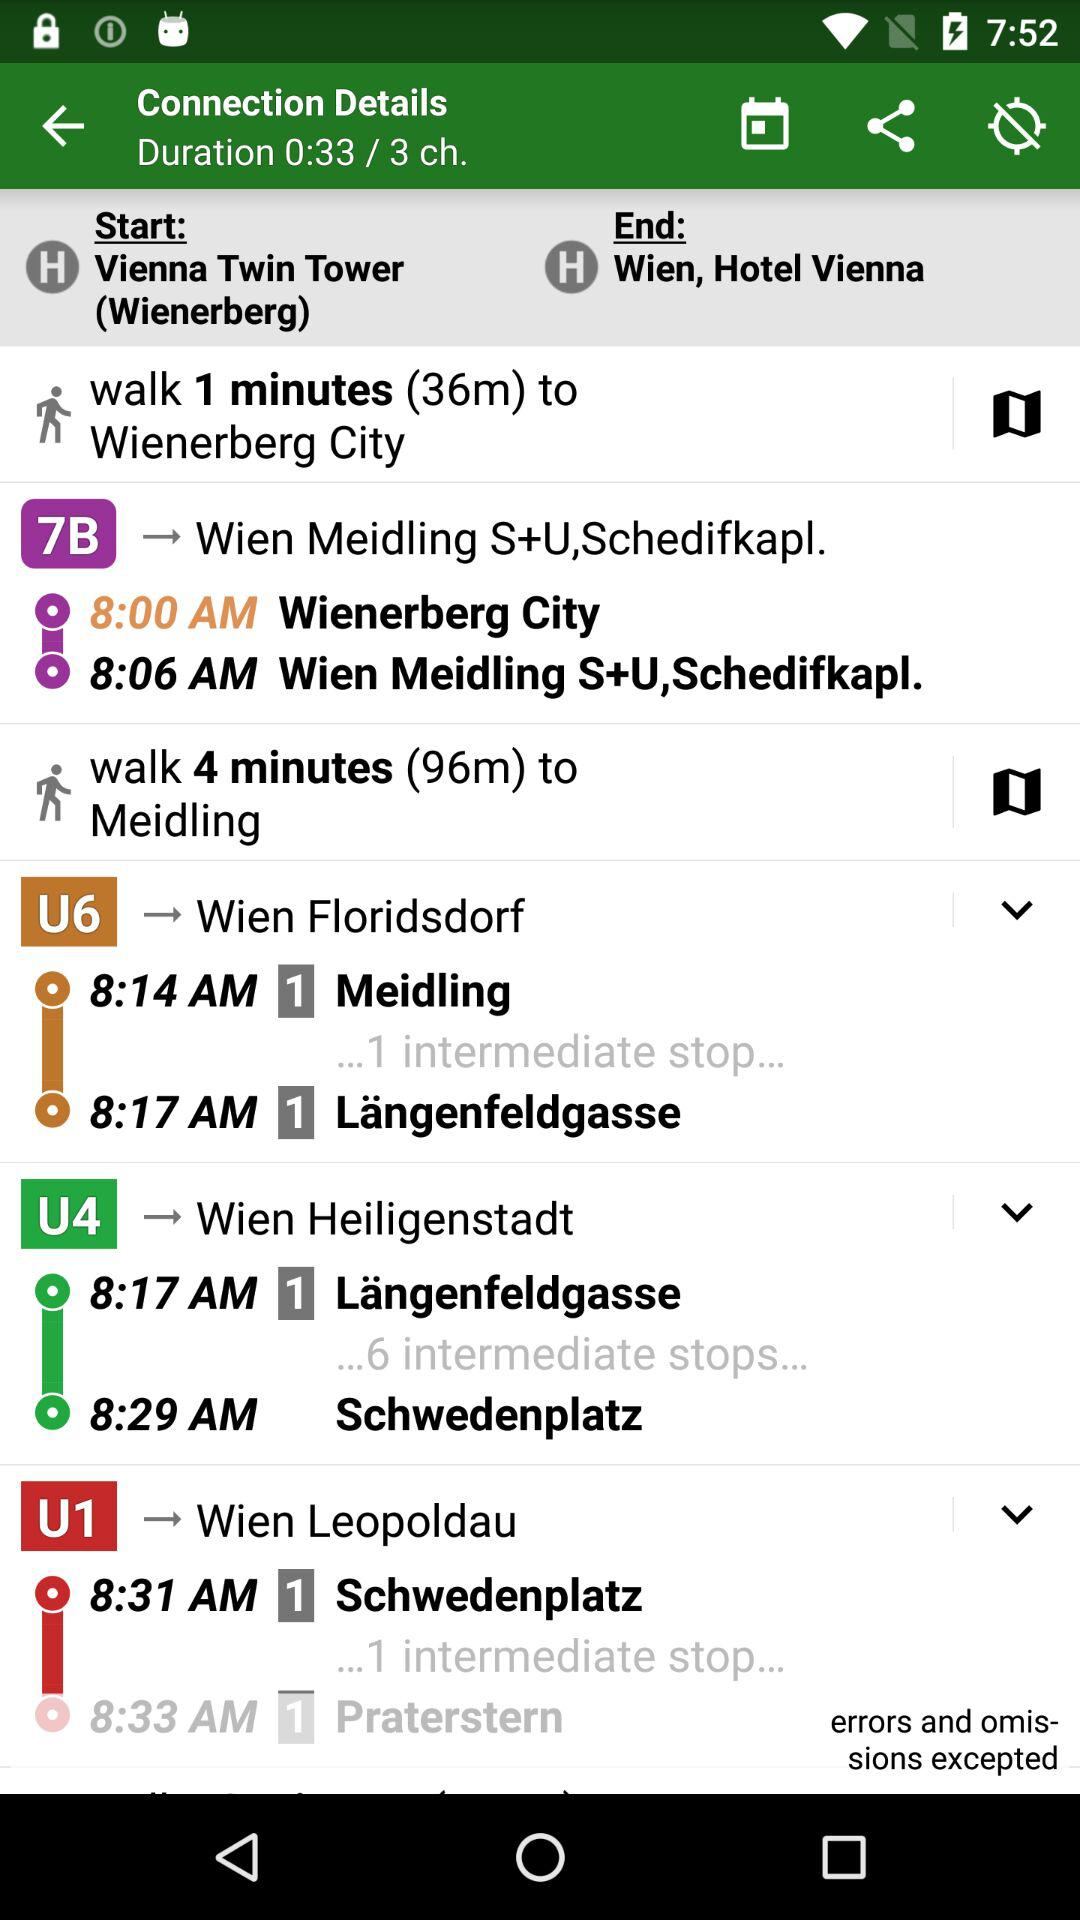What is the end location? The end location is "Hotel Vienna" in Wien. 